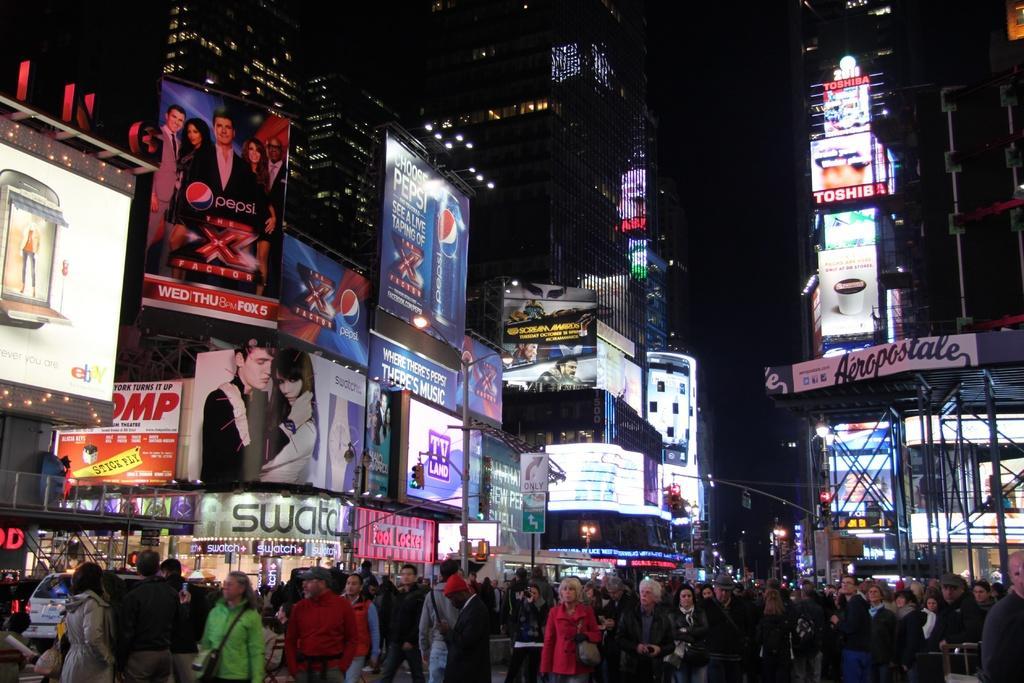In one or two sentences, can you explain what this image depicts? In this image there are a few people walking on the streets and there are cars and sign boards and there are buildings, on the buildings there are billboards. 